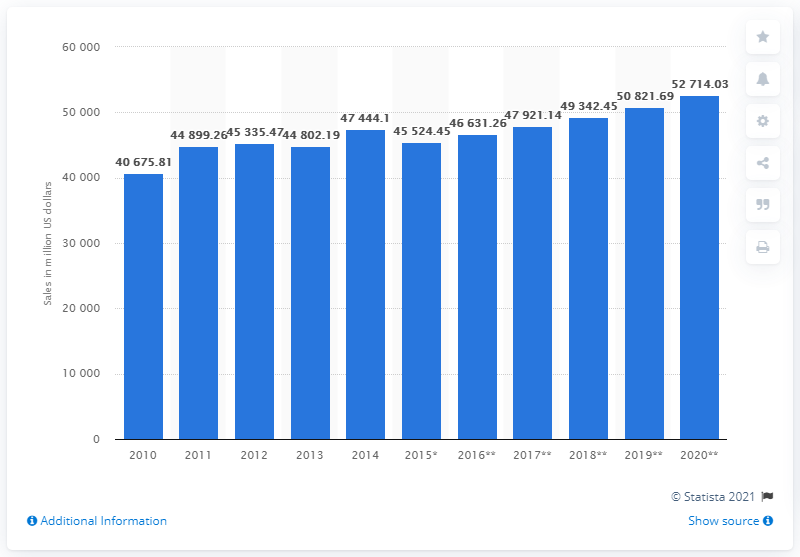Specify some key components in this picture. Tesco's sales forecast for 2020 is to increase by a significant amount, specifically 52,714.03. 